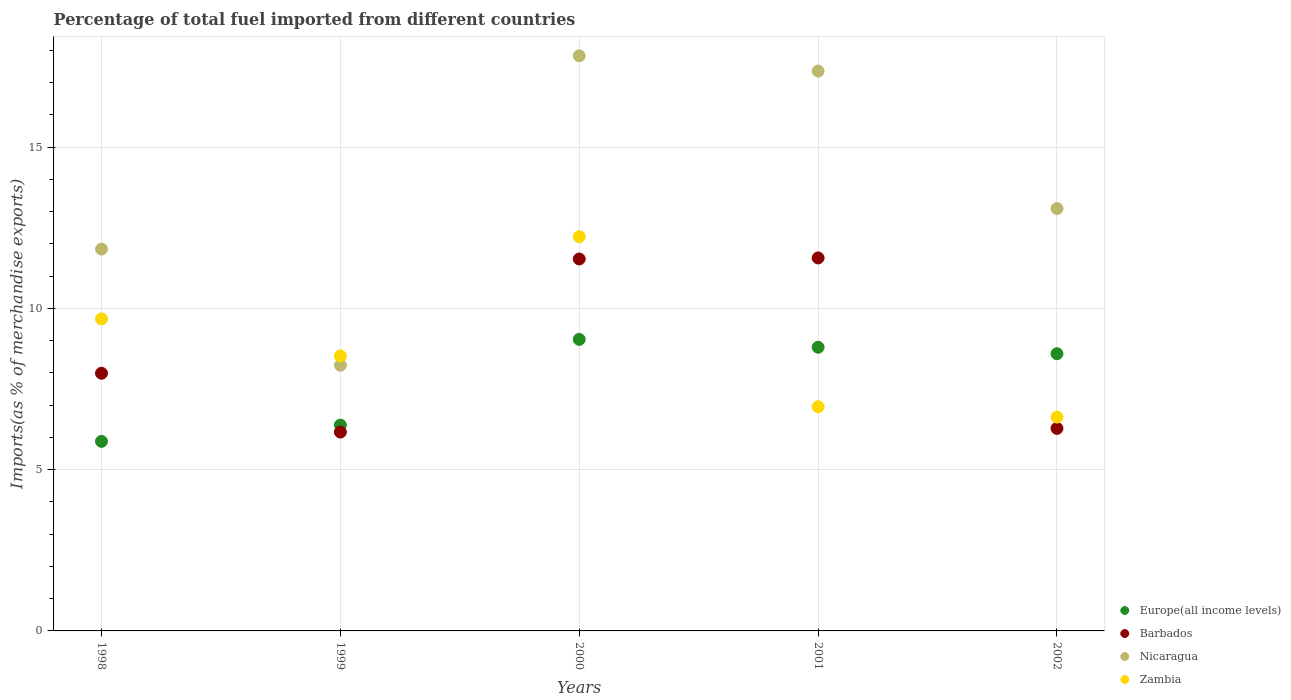What is the percentage of imports to different countries in Zambia in 1998?
Keep it short and to the point. 9.67. Across all years, what is the maximum percentage of imports to different countries in Europe(all income levels)?
Keep it short and to the point. 9.04. Across all years, what is the minimum percentage of imports to different countries in Barbados?
Give a very brief answer. 6.17. In which year was the percentage of imports to different countries in Nicaragua maximum?
Give a very brief answer. 2000. What is the total percentage of imports to different countries in Barbados in the graph?
Provide a short and direct response. 43.53. What is the difference between the percentage of imports to different countries in Barbados in 2000 and that in 2002?
Provide a succinct answer. 5.25. What is the difference between the percentage of imports to different countries in Nicaragua in 1998 and the percentage of imports to different countries in Europe(all income levels) in 1999?
Provide a succinct answer. 5.46. What is the average percentage of imports to different countries in Zambia per year?
Your answer should be very brief. 8.8. In the year 1998, what is the difference between the percentage of imports to different countries in Barbados and percentage of imports to different countries in Europe(all income levels)?
Your answer should be very brief. 2.11. What is the ratio of the percentage of imports to different countries in Zambia in 1999 to that in 2000?
Offer a terse response. 0.7. Is the difference between the percentage of imports to different countries in Barbados in 2000 and 2001 greater than the difference between the percentage of imports to different countries in Europe(all income levels) in 2000 and 2001?
Give a very brief answer. No. What is the difference between the highest and the second highest percentage of imports to different countries in Nicaragua?
Give a very brief answer. 0.47. What is the difference between the highest and the lowest percentage of imports to different countries in Europe(all income levels)?
Offer a terse response. 3.16. In how many years, is the percentage of imports to different countries in Europe(all income levels) greater than the average percentage of imports to different countries in Europe(all income levels) taken over all years?
Offer a terse response. 3. Is it the case that in every year, the sum of the percentage of imports to different countries in Zambia and percentage of imports to different countries in Barbados  is greater than the sum of percentage of imports to different countries in Nicaragua and percentage of imports to different countries in Europe(all income levels)?
Offer a terse response. No. Does the percentage of imports to different countries in Nicaragua monotonically increase over the years?
Ensure brevity in your answer.  No. Is the percentage of imports to different countries in Europe(all income levels) strictly less than the percentage of imports to different countries in Zambia over the years?
Ensure brevity in your answer.  No. How many years are there in the graph?
Offer a very short reply. 5. Does the graph contain any zero values?
Offer a very short reply. No. Where does the legend appear in the graph?
Your answer should be very brief. Bottom right. How many legend labels are there?
Your response must be concise. 4. How are the legend labels stacked?
Ensure brevity in your answer.  Vertical. What is the title of the graph?
Your answer should be compact. Percentage of total fuel imported from different countries. What is the label or title of the Y-axis?
Your response must be concise. Imports(as % of merchandise exports). What is the Imports(as % of merchandise exports) of Europe(all income levels) in 1998?
Ensure brevity in your answer.  5.88. What is the Imports(as % of merchandise exports) in Barbados in 1998?
Offer a very short reply. 7.99. What is the Imports(as % of merchandise exports) in Nicaragua in 1998?
Provide a succinct answer. 11.84. What is the Imports(as % of merchandise exports) of Zambia in 1998?
Offer a very short reply. 9.67. What is the Imports(as % of merchandise exports) of Europe(all income levels) in 1999?
Your response must be concise. 6.38. What is the Imports(as % of merchandise exports) of Barbados in 1999?
Keep it short and to the point. 6.17. What is the Imports(as % of merchandise exports) in Nicaragua in 1999?
Give a very brief answer. 8.24. What is the Imports(as % of merchandise exports) of Zambia in 1999?
Keep it short and to the point. 8.53. What is the Imports(as % of merchandise exports) in Europe(all income levels) in 2000?
Keep it short and to the point. 9.04. What is the Imports(as % of merchandise exports) of Barbados in 2000?
Offer a very short reply. 11.53. What is the Imports(as % of merchandise exports) in Nicaragua in 2000?
Ensure brevity in your answer.  17.83. What is the Imports(as % of merchandise exports) of Zambia in 2000?
Offer a very short reply. 12.22. What is the Imports(as % of merchandise exports) in Europe(all income levels) in 2001?
Ensure brevity in your answer.  8.8. What is the Imports(as % of merchandise exports) in Barbados in 2001?
Your answer should be very brief. 11.56. What is the Imports(as % of merchandise exports) of Nicaragua in 2001?
Offer a terse response. 17.36. What is the Imports(as % of merchandise exports) of Zambia in 2001?
Offer a very short reply. 6.95. What is the Imports(as % of merchandise exports) of Europe(all income levels) in 2002?
Your response must be concise. 8.59. What is the Imports(as % of merchandise exports) of Barbados in 2002?
Keep it short and to the point. 6.28. What is the Imports(as % of merchandise exports) of Nicaragua in 2002?
Offer a very short reply. 13.1. What is the Imports(as % of merchandise exports) in Zambia in 2002?
Give a very brief answer. 6.63. Across all years, what is the maximum Imports(as % of merchandise exports) in Europe(all income levels)?
Your answer should be compact. 9.04. Across all years, what is the maximum Imports(as % of merchandise exports) in Barbados?
Provide a succinct answer. 11.56. Across all years, what is the maximum Imports(as % of merchandise exports) of Nicaragua?
Make the answer very short. 17.83. Across all years, what is the maximum Imports(as % of merchandise exports) in Zambia?
Give a very brief answer. 12.22. Across all years, what is the minimum Imports(as % of merchandise exports) of Europe(all income levels)?
Your response must be concise. 5.88. Across all years, what is the minimum Imports(as % of merchandise exports) of Barbados?
Provide a short and direct response. 6.17. Across all years, what is the minimum Imports(as % of merchandise exports) of Nicaragua?
Your answer should be very brief. 8.24. Across all years, what is the minimum Imports(as % of merchandise exports) of Zambia?
Ensure brevity in your answer.  6.63. What is the total Imports(as % of merchandise exports) of Europe(all income levels) in the graph?
Provide a short and direct response. 38.69. What is the total Imports(as % of merchandise exports) of Barbados in the graph?
Provide a succinct answer. 43.53. What is the total Imports(as % of merchandise exports) in Nicaragua in the graph?
Give a very brief answer. 68.36. What is the total Imports(as % of merchandise exports) of Zambia in the graph?
Provide a succinct answer. 44.01. What is the difference between the Imports(as % of merchandise exports) in Europe(all income levels) in 1998 and that in 1999?
Your response must be concise. -0.51. What is the difference between the Imports(as % of merchandise exports) of Barbados in 1998 and that in 1999?
Keep it short and to the point. 1.82. What is the difference between the Imports(as % of merchandise exports) in Nicaragua in 1998 and that in 1999?
Ensure brevity in your answer.  3.6. What is the difference between the Imports(as % of merchandise exports) of Zambia in 1998 and that in 1999?
Offer a very short reply. 1.15. What is the difference between the Imports(as % of merchandise exports) of Europe(all income levels) in 1998 and that in 2000?
Make the answer very short. -3.16. What is the difference between the Imports(as % of merchandise exports) in Barbados in 1998 and that in 2000?
Your response must be concise. -3.54. What is the difference between the Imports(as % of merchandise exports) in Nicaragua in 1998 and that in 2000?
Your answer should be compact. -5.99. What is the difference between the Imports(as % of merchandise exports) in Zambia in 1998 and that in 2000?
Make the answer very short. -2.55. What is the difference between the Imports(as % of merchandise exports) of Europe(all income levels) in 1998 and that in 2001?
Offer a terse response. -2.92. What is the difference between the Imports(as % of merchandise exports) in Barbados in 1998 and that in 2001?
Your response must be concise. -3.58. What is the difference between the Imports(as % of merchandise exports) in Nicaragua in 1998 and that in 2001?
Make the answer very short. -5.52. What is the difference between the Imports(as % of merchandise exports) in Zambia in 1998 and that in 2001?
Your response must be concise. 2.72. What is the difference between the Imports(as % of merchandise exports) in Europe(all income levels) in 1998 and that in 2002?
Ensure brevity in your answer.  -2.72. What is the difference between the Imports(as % of merchandise exports) in Barbados in 1998 and that in 2002?
Give a very brief answer. 1.71. What is the difference between the Imports(as % of merchandise exports) of Nicaragua in 1998 and that in 2002?
Keep it short and to the point. -1.26. What is the difference between the Imports(as % of merchandise exports) in Zambia in 1998 and that in 2002?
Your answer should be very brief. 3.04. What is the difference between the Imports(as % of merchandise exports) of Europe(all income levels) in 1999 and that in 2000?
Your response must be concise. -2.66. What is the difference between the Imports(as % of merchandise exports) in Barbados in 1999 and that in 2000?
Make the answer very short. -5.37. What is the difference between the Imports(as % of merchandise exports) in Nicaragua in 1999 and that in 2000?
Your answer should be very brief. -9.59. What is the difference between the Imports(as % of merchandise exports) in Zambia in 1999 and that in 2000?
Make the answer very short. -3.7. What is the difference between the Imports(as % of merchandise exports) in Europe(all income levels) in 1999 and that in 2001?
Your answer should be very brief. -2.41. What is the difference between the Imports(as % of merchandise exports) of Barbados in 1999 and that in 2001?
Keep it short and to the point. -5.4. What is the difference between the Imports(as % of merchandise exports) in Nicaragua in 1999 and that in 2001?
Provide a succinct answer. -9.12. What is the difference between the Imports(as % of merchandise exports) in Zambia in 1999 and that in 2001?
Ensure brevity in your answer.  1.57. What is the difference between the Imports(as % of merchandise exports) of Europe(all income levels) in 1999 and that in 2002?
Your answer should be compact. -2.21. What is the difference between the Imports(as % of merchandise exports) in Barbados in 1999 and that in 2002?
Your response must be concise. -0.11. What is the difference between the Imports(as % of merchandise exports) of Nicaragua in 1999 and that in 2002?
Keep it short and to the point. -4.86. What is the difference between the Imports(as % of merchandise exports) of Zambia in 1999 and that in 2002?
Ensure brevity in your answer.  1.9. What is the difference between the Imports(as % of merchandise exports) in Europe(all income levels) in 2000 and that in 2001?
Offer a very short reply. 0.24. What is the difference between the Imports(as % of merchandise exports) of Barbados in 2000 and that in 2001?
Your answer should be very brief. -0.03. What is the difference between the Imports(as % of merchandise exports) in Nicaragua in 2000 and that in 2001?
Make the answer very short. 0.47. What is the difference between the Imports(as % of merchandise exports) of Zambia in 2000 and that in 2001?
Ensure brevity in your answer.  5.27. What is the difference between the Imports(as % of merchandise exports) in Europe(all income levels) in 2000 and that in 2002?
Your answer should be compact. 0.45. What is the difference between the Imports(as % of merchandise exports) of Barbados in 2000 and that in 2002?
Offer a very short reply. 5.25. What is the difference between the Imports(as % of merchandise exports) in Nicaragua in 2000 and that in 2002?
Offer a very short reply. 4.73. What is the difference between the Imports(as % of merchandise exports) in Zambia in 2000 and that in 2002?
Offer a terse response. 5.59. What is the difference between the Imports(as % of merchandise exports) in Europe(all income levels) in 2001 and that in 2002?
Provide a short and direct response. 0.2. What is the difference between the Imports(as % of merchandise exports) in Barbados in 2001 and that in 2002?
Your answer should be compact. 5.28. What is the difference between the Imports(as % of merchandise exports) in Nicaragua in 2001 and that in 2002?
Provide a succinct answer. 4.26. What is the difference between the Imports(as % of merchandise exports) in Zambia in 2001 and that in 2002?
Keep it short and to the point. 0.32. What is the difference between the Imports(as % of merchandise exports) in Europe(all income levels) in 1998 and the Imports(as % of merchandise exports) in Barbados in 1999?
Your answer should be very brief. -0.29. What is the difference between the Imports(as % of merchandise exports) in Europe(all income levels) in 1998 and the Imports(as % of merchandise exports) in Nicaragua in 1999?
Your response must be concise. -2.36. What is the difference between the Imports(as % of merchandise exports) of Europe(all income levels) in 1998 and the Imports(as % of merchandise exports) of Zambia in 1999?
Offer a terse response. -2.65. What is the difference between the Imports(as % of merchandise exports) in Barbados in 1998 and the Imports(as % of merchandise exports) in Nicaragua in 1999?
Give a very brief answer. -0.25. What is the difference between the Imports(as % of merchandise exports) of Barbados in 1998 and the Imports(as % of merchandise exports) of Zambia in 1999?
Your response must be concise. -0.54. What is the difference between the Imports(as % of merchandise exports) of Nicaragua in 1998 and the Imports(as % of merchandise exports) of Zambia in 1999?
Ensure brevity in your answer.  3.31. What is the difference between the Imports(as % of merchandise exports) in Europe(all income levels) in 1998 and the Imports(as % of merchandise exports) in Barbados in 2000?
Make the answer very short. -5.66. What is the difference between the Imports(as % of merchandise exports) in Europe(all income levels) in 1998 and the Imports(as % of merchandise exports) in Nicaragua in 2000?
Provide a succinct answer. -11.95. What is the difference between the Imports(as % of merchandise exports) in Europe(all income levels) in 1998 and the Imports(as % of merchandise exports) in Zambia in 2000?
Your answer should be compact. -6.35. What is the difference between the Imports(as % of merchandise exports) in Barbados in 1998 and the Imports(as % of merchandise exports) in Nicaragua in 2000?
Make the answer very short. -9.84. What is the difference between the Imports(as % of merchandise exports) in Barbados in 1998 and the Imports(as % of merchandise exports) in Zambia in 2000?
Provide a short and direct response. -4.24. What is the difference between the Imports(as % of merchandise exports) in Nicaragua in 1998 and the Imports(as % of merchandise exports) in Zambia in 2000?
Your answer should be very brief. -0.39. What is the difference between the Imports(as % of merchandise exports) of Europe(all income levels) in 1998 and the Imports(as % of merchandise exports) of Barbados in 2001?
Your answer should be very brief. -5.69. What is the difference between the Imports(as % of merchandise exports) of Europe(all income levels) in 1998 and the Imports(as % of merchandise exports) of Nicaragua in 2001?
Your answer should be very brief. -11.48. What is the difference between the Imports(as % of merchandise exports) of Europe(all income levels) in 1998 and the Imports(as % of merchandise exports) of Zambia in 2001?
Your response must be concise. -1.07. What is the difference between the Imports(as % of merchandise exports) in Barbados in 1998 and the Imports(as % of merchandise exports) in Nicaragua in 2001?
Your answer should be very brief. -9.37. What is the difference between the Imports(as % of merchandise exports) in Barbados in 1998 and the Imports(as % of merchandise exports) in Zambia in 2001?
Give a very brief answer. 1.04. What is the difference between the Imports(as % of merchandise exports) of Nicaragua in 1998 and the Imports(as % of merchandise exports) of Zambia in 2001?
Make the answer very short. 4.89. What is the difference between the Imports(as % of merchandise exports) of Europe(all income levels) in 1998 and the Imports(as % of merchandise exports) of Barbados in 2002?
Provide a succinct answer. -0.4. What is the difference between the Imports(as % of merchandise exports) of Europe(all income levels) in 1998 and the Imports(as % of merchandise exports) of Nicaragua in 2002?
Your answer should be compact. -7.22. What is the difference between the Imports(as % of merchandise exports) of Europe(all income levels) in 1998 and the Imports(as % of merchandise exports) of Zambia in 2002?
Keep it short and to the point. -0.75. What is the difference between the Imports(as % of merchandise exports) of Barbados in 1998 and the Imports(as % of merchandise exports) of Nicaragua in 2002?
Keep it short and to the point. -5.11. What is the difference between the Imports(as % of merchandise exports) in Barbados in 1998 and the Imports(as % of merchandise exports) in Zambia in 2002?
Provide a succinct answer. 1.36. What is the difference between the Imports(as % of merchandise exports) in Nicaragua in 1998 and the Imports(as % of merchandise exports) in Zambia in 2002?
Offer a very short reply. 5.21. What is the difference between the Imports(as % of merchandise exports) of Europe(all income levels) in 1999 and the Imports(as % of merchandise exports) of Barbados in 2000?
Provide a succinct answer. -5.15. What is the difference between the Imports(as % of merchandise exports) of Europe(all income levels) in 1999 and the Imports(as % of merchandise exports) of Nicaragua in 2000?
Offer a very short reply. -11.45. What is the difference between the Imports(as % of merchandise exports) of Europe(all income levels) in 1999 and the Imports(as % of merchandise exports) of Zambia in 2000?
Your response must be concise. -5.84. What is the difference between the Imports(as % of merchandise exports) of Barbados in 1999 and the Imports(as % of merchandise exports) of Nicaragua in 2000?
Your answer should be very brief. -11.66. What is the difference between the Imports(as % of merchandise exports) of Barbados in 1999 and the Imports(as % of merchandise exports) of Zambia in 2000?
Your answer should be very brief. -6.06. What is the difference between the Imports(as % of merchandise exports) of Nicaragua in 1999 and the Imports(as % of merchandise exports) of Zambia in 2000?
Provide a short and direct response. -3.99. What is the difference between the Imports(as % of merchandise exports) of Europe(all income levels) in 1999 and the Imports(as % of merchandise exports) of Barbados in 2001?
Offer a terse response. -5.18. What is the difference between the Imports(as % of merchandise exports) of Europe(all income levels) in 1999 and the Imports(as % of merchandise exports) of Nicaragua in 2001?
Keep it short and to the point. -10.98. What is the difference between the Imports(as % of merchandise exports) of Europe(all income levels) in 1999 and the Imports(as % of merchandise exports) of Zambia in 2001?
Make the answer very short. -0.57. What is the difference between the Imports(as % of merchandise exports) of Barbados in 1999 and the Imports(as % of merchandise exports) of Nicaragua in 2001?
Keep it short and to the point. -11.19. What is the difference between the Imports(as % of merchandise exports) of Barbados in 1999 and the Imports(as % of merchandise exports) of Zambia in 2001?
Keep it short and to the point. -0.79. What is the difference between the Imports(as % of merchandise exports) in Nicaragua in 1999 and the Imports(as % of merchandise exports) in Zambia in 2001?
Offer a very short reply. 1.29. What is the difference between the Imports(as % of merchandise exports) of Europe(all income levels) in 1999 and the Imports(as % of merchandise exports) of Barbados in 2002?
Make the answer very short. 0.1. What is the difference between the Imports(as % of merchandise exports) in Europe(all income levels) in 1999 and the Imports(as % of merchandise exports) in Nicaragua in 2002?
Provide a succinct answer. -6.71. What is the difference between the Imports(as % of merchandise exports) in Europe(all income levels) in 1999 and the Imports(as % of merchandise exports) in Zambia in 2002?
Keep it short and to the point. -0.25. What is the difference between the Imports(as % of merchandise exports) of Barbados in 1999 and the Imports(as % of merchandise exports) of Nicaragua in 2002?
Ensure brevity in your answer.  -6.93. What is the difference between the Imports(as % of merchandise exports) of Barbados in 1999 and the Imports(as % of merchandise exports) of Zambia in 2002?
Make the answer very short. -0.46. What is the difference between the Imports(as % of merchandise exports) in Nicaragua in 1999 and the Imports(as % of merchandise exports) in Zambia in 2002?
Your response must be concise. 1.61. What is the difference between the Imports(as % of merchandise exports) of Europe(all income levels) in 2000 and the Imports(as % of merchandise exports) of Barbados in 2001?
Your response must be concise. -2.52. What is the difference between the Imports(as % of merchandise exports) of Europe(all income levels) in 2000 and the Imports(as % of merchandise exports) of Nicaragua in 2001?
Ensure brevity in your answer.  -8.32. What is the difference between the Imports(as % of merchandise exports) in Europe(all income levels) in 2000 and the Imports(as % of merchandise exports) in Zambia in 2001?
Your answer should be very brief. 2.09. What is the difference between the Imports(as % of merchandise exports) in Barbados in 2000 and the Imports(as % of merchandise exports) in Nicaragua in 2001?
Give a very brief answer. -5.83. What is the difference between the Imports(as % of merchandise exports) of Barbados in 2000 and the Imports(as % of merchandise exports) of Zambia in 2001?
Your answer should be very brief. 4.58. What is the difference between the Imports(as % of merchandise exports) in Nicaragua in 2000 and the Imports(as % of merchandise exports) in Zambia in 2001?
Offer a terse response. 10.88. What is the difference between the Imports(as % of merchandise exports) in Europe(all income levels) in 2000 and the Imports(as % of merchandise exports) in Barbados in 2002?
Give a very brief answer. 2.76. What is the difference between the Imports(as % of merchandise exports) in Europe(all income levels) in 2000 and the Imports(as % of merchandise exports) in Nicaragua in 2002?
Provide a short and direct response. -4.06. What is the difference between the Imports(as % of merchandise exports) in Europe(all income levels) in 2000 and the Imports(as % of merchandise exports) in Zambia in 2002?
Your response must be concise. 2.41. What is the difference between the Imports(as % of merchandise exports) of Barbados in 2000 and the Imports(as % of merchandise exports) of Nicaragua in 2002?
Provide a short and direct response. -1.56. What is the difference between the Imports(as % of merchandise exports) in Barbados in 2000 and the Imports(as % of merchandise exports) in Zambia in 2002?
Your response must be concise. 4.9. What is the difference between the Imports(as % of merchandise exports) of Nicaragua in 2000 and the Imports(as % of merchandise exports) of Zambia in 2002?
Provide a short and direct response. 11.2. What is the difference between the Imports(as % of merchandise exports) in Europe(all income levels) in 2001 and the Imports(as % of merchandise exports) in Barbados in 2002?
Offer a terse response. 2.52. What is the difference between the Imports(as % of merchandise exports) in Europe(all income levels) in 2001 and the Imports(as % of merchandise exports) in Nicaragua in 2002?
Your response must be concise. -4.3. What is the difference between the Imports(as % of merchandise exports) of Europe(all income levels) in 2001 and the Imports(as % of merchandise exports) of Zambia in 2002?
Your answer should be very brief. 2.16. What is the difference between the Imports(as % of merchandise exports) of Barbados in 2001 and the Imports(as % of merchandise exports) of Nicaragua in 2002?
Offer a terse response. -1.53. What is the difference between the Imports(as % of merchandise exports) of Barbados in 2001 and the Imports(as % of merchandise exports) of Zambia in 2002?
Your answer should be very brief. 4.93. What is the difference between the Imports(as % of merchandise exports) in Nicaragua in 2001 and the Imports(as % of merchandise exports) in Zambia in 2002?
Keep it short and to the point. 10.73. What is the average Imports(as % of merchandise exports) in Europe(all income levels) per year?
Provide a succinct answer. 7.74. What is the average Imports(as % of merchandise exports) of Barbados per year?
Your answer should be compact. 8.71. What is the average Imports(as % of merchandise exports) of Nicaragua per year?
Ensure brevity in your answer.  13.67. What is the average Imports(as % of merchandise exports) in Zambia per year?
Your answer should be very brief. 8.8. In the year 1998, what is the difference between the Imports(as % of merchandise exports) in Europe(all income levels) and Imports(as % of merchandise exports) in Barbados?
Offer a terse response. -2.11. In the year 1998, what is the difference between the Imports(as % of merchandise exports) in Europe(all income levels) and Imports(as % of merchandise exports) in Nicaragua?
Ensure brevity in your answer.  -5.96. In the year 1998, what is the difference between the Imports(as % of merchandise exports) in Europe(all income levels) and Imports(as % of merchandise exports) in Zambia?
Offer a very short reply. -3.8. In the year 1998, what is the difference between the Imports(as % of merchandise exports) of Barbados and Imports(as % of merchandise exports) of Nicaragua?
Ensure brevity in your answer.  -3.85. In the year 1998, what is the difference between the Imports(as % of merchandise exports) of Barbados and Imports(as % of merchandise exports) of Zambia?
Make the answer very short. -1.69. In the year 1998, what is the difference between the Imports(as % of merchandise exports) in Nicaragua and Imports(as % of merchandise exports) in Zambia?
Offer a very short reply. 2.16. In the year 1999, what is the difference between the Imports(as % of merchandise exports) in Europe(all income levels) and Imports(as % of merchandise exports) in Barbados?
Your answer should be compact. 0.22. In the year 1999, what is the difference between the Imports(as % of merchandise exports) in Europe(all income levels) and Imports(as % of merchandise exports) in Nicaragua?
Your response must be concise. -1.85. In the year 1999, what is the difference between the Imports(as % of merchandise exports) of Europe(all income levels) and Imports(as % of merchandise exports) of Zambia?
Provide a short and direct response. -2.14. In the year 1999, what is the difference between the Imports(as % of merchandise exports) in Barbados and Imports(as % of merchandise exports) in Nicaragua?
Offer a terse response. -2.07. In the year 1999, what is the difference between the Imports(as % of merchandise exports) of Barbados and Imports(as % of merchandise exports) of Zambia?
Your answer should be very brief. -2.36. In the year 1999, what is the difference between the Imports(as % of merchandise exports) of Nicaragua and Imports(as % of merchandise exports) of Zambia?
Ensure brevity in your answer.  -0.29. In the year 2000, what is the difference between the Imports(as % of merchandise exports) in Europe(all income levels) and Imports(as % of merchandise exports) in Barbados?
Your answer should be very brief. -2.49. In the year 2000, what is the difference between the Imports(as % of merchandise exports) in Europe(all income levels) and Imports(as % of merchandise exports) in Nicaragua?
Make the answer very short. -8.79. In the year 2000, what is the difference between the Imports(as % of merchandise exports) of Europe(all income levels) and Imports(as % of merchandise exports) of Zambia?
Make the answer very short. -3.18. In the year 2000, what is the difference between the Imports(as % of merchandise exports) of Barbados and Imports(as % of merchandise exports) of Nicaragua?
Provide a succinct answer. -6.3. In the year 2000, what is the difference between the Imports(as % of merchandise exports) of Barbados and Imports(as % of merchandise exports) of Zambia?
Ensure brevity in your answer.  -0.69. In the year 2000, what is the difference between the Imports(as % of merchandise exports) in Nicaragua and Imports(as % of merchandise exports) in Zambia?
Give a very brief answer. 5.61. In the year 2001, what is the difference between the Imports(as % of merchandise exports) of Europe(all income levels) and Imports(as % of merchandise exports) of Barbados?
Provide a succinct answer. -2.77. In the year 2001, what is the difference between the Imports(as % of merchandise exports) of Europe(all income levels) and Imports(as % of merchandise exports) of Nicaragua?
Make the answer very short. -8.56. In the year 2001, what is the difference between the Imports(as % of merchandise exports) in Europe(all income levels) and Imports(as % of merchandise exports) in Zambia?
Your response must be concise. 1.84. In the year 2001, what is the difference between the Imports(as % of merchandise exports) in Barbados and Imports(as % of merchandise exports) in Nicaragua?
Give a very brief answer. -5.8. In the year 2001, what is the difference between the Imports(as % of merchandise exports) of Barbados and Imports(as % of merchandise exports) of Zambia?
Offer a terse response. 4.61. In the year 2001, what is the difference between the Imports(as % of merchandise exports) in Nicaragua and Imports(as % of merchandise exports) in Zambia?
Provide a short and direct response. 10.41. In the year 2002, what is the difference between the Imports(as % of merchandise exports) in Europe(all income levels) and Imports(as % of merchandise exports) in Barbados?
Offer a terse response. 2.31. In the year 2002, what is the difference between the Imports(as % of merchandise exports) in Europe(all income levels) and Imports(as % of merchandise exports) in Nicaragua?
Make the answer very short. -4.5. In the year 2002, what is the difference between the Imports(as % of merchandise exports) of Europe(all income levels) and Imports(as % of merchandise exports) of Zambia?
Offer a very short reply. 1.96. In the year 2002, what is the difference between the Imports(as % of merchandise exports) in Barbados and Imports(as % of merchandise exports) in Nicaragua?
Give a very brief answer. -6.82. In the year 2002, what is the difference between the Imports(as % of merchandise exports) of Barbados and Imports(as % of merchandise exports) of Zambia?
Give a very brief answer. -0.35. In the year 2002, what is the difference between the Imports(as % of merchandise exports) in Nicaragua and Imports(as % of merchandise exports) in Zambia?
Provide a short and direct response. 6.47. What is the ratio of the Imports(as % of merchandise exports) in Europe(all income levels) in 1998 to that in 1999?
Your response must be concise. 0.92. What is the ratio of the Imports(as % of merchandise exports) of Barbados in 1998 to that in 1999?
Your response must be concise. 1.3. What is the ratio of the Imports(as % of merchandise exports) in Nicaragua in 1998 to that in 1999?
Ensure brevity in your answer.  1.44. What is the ratio of the Imports(as % of merchandise exports) of Zambia in 1998 to that in 1999?
Your answer should be very brief. 1.13. What is the ratio of the Imports(as % of merchandise exports) of Europe(all income levels) in 1998 to that in 2000?
Give a very brief answer. 0.65. What is the ratio of the Imports(as % of merchandise exports) in Barbados in 1998 to that in 2000?
Your answer should be compact. 0.69. What is the ratio of the Imports(as % of merchandise exports) of Nicaragua in 1998 to that in 2000?
Keep it short and to the point. 0.66. What is the ratio of the Imports(as % of merchandise exports) in Zambia in 1998 to that in 2000?
Provide a short and direct response. 0.79. What is the ratio of the Imports(as % of merchandise exports) of Europe(all income levels) in 1998 to that in 2001?
Offer a terse response. 0.67. What is the ratio of the Imports(as % of merchandise exports) of Barbados in 1998 to that in 2001?
Make the answer very short. 0.69. What is the ratio of the Imports(as % of merchandise exports) in Nicaragua in 1998 to that in 2001?
Keep it short and to the point. 0.68. What is the ratio of the Imports(as % of merchandise exports) of Zambia in 1998 to that in 2001?
Provide a succinct answer. 1.39. What is the ratio of the Imports(as % of merchandise exports) in Europe(all income levels) in 1998 to that in 2002?
Offer a terse response. 0.68. What is the ratio of the Imports(as % of merchandise exports) in Barbados in 1998 to that in 2002?
Ensure brevity in your answer.  1.27. What is the ratio of the Imports(as % of merchandise exports) of Nicaragua in 1998 to that in 2002?
Make the answer very short. 0.9. What is the ratio of the Imports(as % of merchandise exports) of Zambia in 1998 to that in 2002?
Your answer should be very brief. 1.46. What is the ratio of the Imports(as % of merchandise exports) in Europe(all income levels) in 1999 to that in 2000?
Your answer should be very brief. 0.71. What is the ratio of the Imports(as % of merchandise exports) in Barbados in 1999 to that in 2000?
Your answer should be compact. 0.53. What is the ratio of the Imports(as % of merchandise exports) of Nicaragua in 1999 to that in 2000?
Give a very brief answer. 0.46. What is the ratio of the Imports(as % of merchandise exports) of Zambia in 1999 to that in 2000?
Your response must be concise. 0.7. What is the ratio of the Imports(as % of merchandise exports) in Europe(all income levels) in 1999 to that in 2001?
Your answer should be very brief. 0.73. What is the ratio of the Imports(as % of merchandise exports) of Barbados in 1999 to that in 2001?
Ensure brevity in your answer.  0.53. What is the ratio of the Imports(as % of merchandise exports) in Nicaragua in 1999 to that in 2001?
Give a very brief answer. 0.47. What is the ratio of the Imports(as % of merchandise exports) of Zambia in 1999 to that in 2001?
Make the answer very short. 1.23. What is the ratio of the Imports(as % of merchandise exports) in Europe(all income levels) in 1999 to that in 2002?
Ensure brevity in your answer.  0.74. What is the ratio of the Imports(as % of merchandise exports) in Barbados in 1999 to that in 2002?
Offer a terse response. 0.98. What is the ratio of the Imports(as % of merchandise exports) in Nicaragua in 1999 to that in 2002?
Your answer should be compact. 0.63. What is the ratio of the Imports(as % of merchandise exports) in Zambia in 1999 to that in 2002?
Provide a short and direct response. 1.29. What is the ratio of the Imports(as % of merchandise exports) of Europe(all income levels) in 2000 to that in 2001?
Your answer should be very brief. 1.03. What is the ratio of the Imports(as % of merchandise exports) of Nicaragua in 2000 to that in 2001?
Your answer should be very brief. 1.03. What is the ratio of the Imports(as % of merchandise exports) in Zambia in 2000 to that in 2001?
Your answer should be compact. 1.76. What is the ratio of the Imports(as % of merchandise exports) of Europe(all income levels) in 2000 to that in 2002?
Make the answer very short. 1.05. What is the ratio of the Imports(as % of merchandise exports) of Barbados in 2000 to that in 2002?
Your answer should be compact. 1.84. What is the ratio of the Imports(as % of merchandise exports) of Nicaragua in 2000 to that in 2002?
Keep it short and to the point. 1.36. What is the ratio of the Imports(as % of merchandise exports) in Zambia in 2000 to that in 2002?
Offer a terse response. 1.84. What is the ratio of the Imports(as % of merchandise exports) in Europe(all income levels) in 2001 to that in 2002?
Offer a very short reply. 1.02. What is the ratio of the Imports(as % of merchandise exports) in Barbados in 2001 to that in 2002?
Provide a succinct answer. 1.84. What is the ratio of the Imports(as % of merchandise exports) in Nicaragua in 2001 to that in 2002?
Keep it short and to the point. 1.33. What is the ratio of the Imports(as % of merchandise exports) in Zambia in 2001 to that in 2002?
Offer a terse response. 1.05. What is the difference between the highest and the second highest Imports(as % of merchandise exports) in Europe(all income levels)?
Keep it short and to the point. 0.24. What is the difference between the highest and the second highest Imports(as % of merchandise exports) in Barbados?
Your answer should be very brief. 0.03. What is the difference between the highest and the second highest Imports(as % of merchandise exports) in Nicaragua?
Provide a succinct answer. 0.47. What is the difference between the highest and the second highest Imports(as % of merchandise exports) of Zambia?
Give a very brief answer. 2.55. What is the difference between the highest and the lowest Imports(as % of merchandise exports) in Europe(all income levels)?
Provide a succinct answer. 3.16. What is the difference between the highest and the lowest Imports(as % of merchandise exports) of Barbados?
Offer a very short reply. 5.4. What is the difference between the highest and the lowest Imports(as % of merchandise exports) of Nicaragua?
Keep it short and to the point. 9.59. What is the difference between the highest and the lowest Imports(as % of merchandise exports) in Zambia?
Offer a terse response. 5.59. 